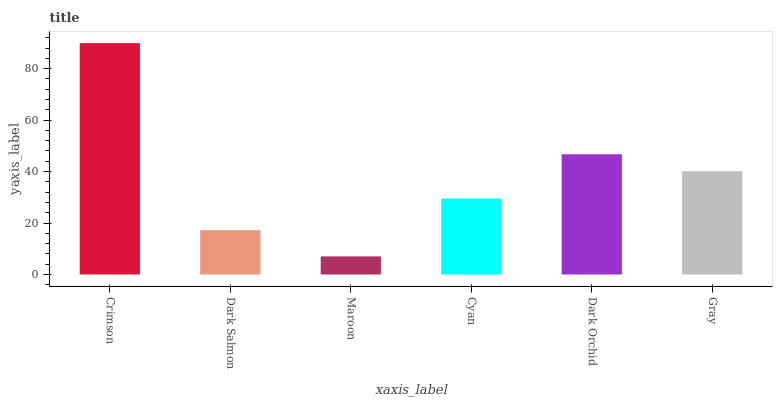Is Maroon the minimum?
Answer yes or no. Yes. Is Crimson the maximum?
Answer yes or no. Yes. Is Dark Salmon the minimum?
Answer yes or no. No. Is Dark Salmon the maximum?
Answer yes or no. No. Is Crimson greater than Dark Salmon?
Answer yes or no. Yes. Is Dark Salmon less than Crimson?
Answer yes or no. Yes. Is Dark Salmon greater than Crimson?
Answer yes or no. No. Is Crimson less than Dark Salmon?
Answer yes or no. No. Is Gray the high median?
Answer yes or no. Yes. Is Cyan the low median?
Answer yes or no. Yes. Is Dark Salmon the high median?
Answer yes or no. No. Is Dark Orchid the low median?
Answer yes or no. No. 